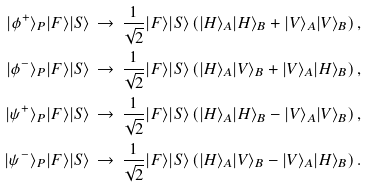<formula> <loc_0><loc_0><loc_500><loc_500>| \phi ^ { + } \rangle _ { P } | F \rangle | S \rangle & \, \rightarrow \, \frac { 1 } { \sqrt { 2 } } | F \rangle | S \rangle \left ( | H \rangle _ { A } | H \rangle _ { B } + | V \rangle _ { A } | V \rangle _ { B } \right ) , \\ | \phi ^ { - } \rangle _ { P } | F \rangle | S \rangle & \, \rightarrow \, \frac { 1 } { \sqrt { 2 } } | F \rangle | S \rangle \left ( | H \rangle _ { A } | V \rangle _ { B } + | V \rangle _ { A } | H \rangle _ { B } \right ) , \\ | \psi ^ { + } \rangle _ { P } | F \rangle | S \rangle & \, \rightarrow \, \frac { 1 } { \sqrt { 2 } } | F \rangle | S \rangle \left ( | H \rangle _ { A } | H \rangle _ { B } - | V \rangle _ { A } | V \rangle _ { B } \right ) , \\ | \psi ^ { - } \rangle _ { P } | F \rangle | S \rangle & \, \rightarrow \, \frac { 1 } { \sqrt { 2 } } | F \rangle | S \rangle \left ( | H \rangle _ { A } | V \rangle _ { B } - | V \rangle _ { A } | H \rangle _ { B } \right ) .</formula> 